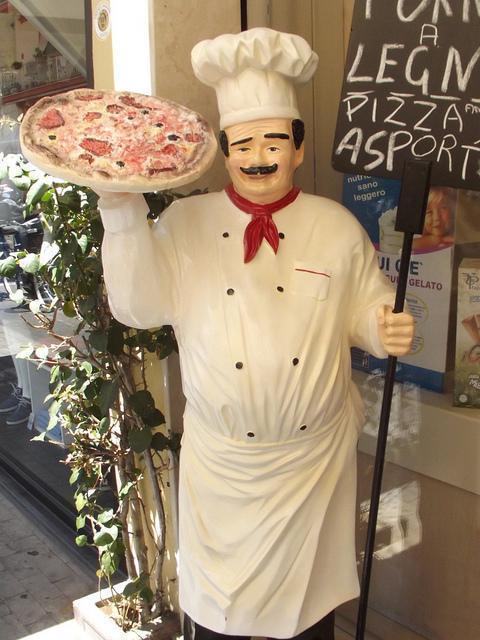Evaluate: Does the caption "The potted plant is across from the pizza." match the image?
Answer yes or no. No. 